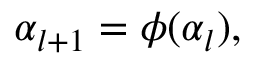<formula> <loc_0><loc_0><loc_500><loc_500>\alpha _ { l + 1 } = \phi ( \alpha _ { l } ) ,</formula> 